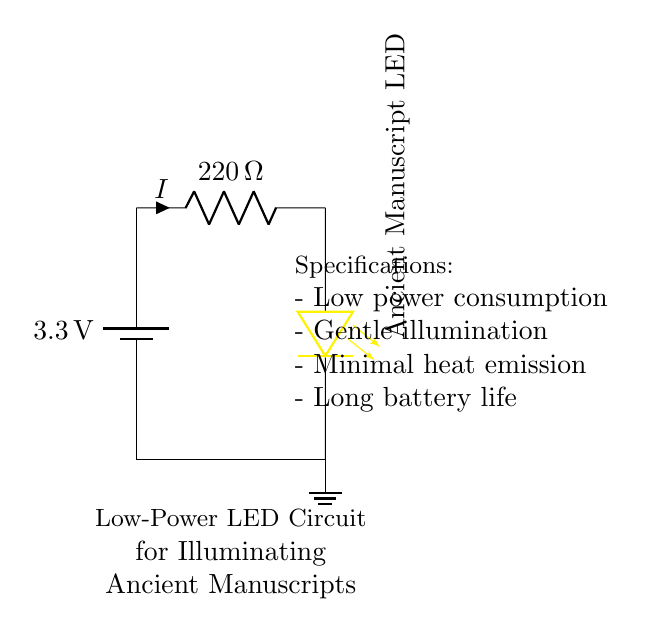What is the voltage of this circuit? The voltage is 3.3 volts, as indicated by the battery in the circuit diagram that provides this potential difference.
Answer: 3.3 volts What type of component is used for limiting current? The circuit uses a resistor marked as 220 ohms for current limiting. This resistor is placed in series with the LED, controlling the flow of current to prevent damage to the LED.
Answer: 220 ohms What color is the LED used in this circuit? The LED is yellow, as specified in the circuit diagram next to the LED symbol. This indicates the color of light that the LED emits when powered.
Answer: Yellow What is the purpose of the resistor in this circuit? The resistor limits the current flowing through the LED to prevent it from being damaged by excessive current. In conjunction with the LED, it ensures that the current is kept at a safe level for reliable operation.
Answer: Current limiting How does this circuit ensure long battery life? The circuit uses low power components, specifically a low-power LED and a current limiting resistor, which together minimize power consumption and thus prolong battery life. A low current draw from the battery means it lasts longer before needing replacement.
Answer: Low power consumption Is this circuit designed for high heat generation? No, it is designed for minimal heat emission, as LED and resistor values indicate that they operate efficiently with lower power levels, avoiding excess heat that could damage the manuscripts being illuminated.
Answer: Minimal heat emission 